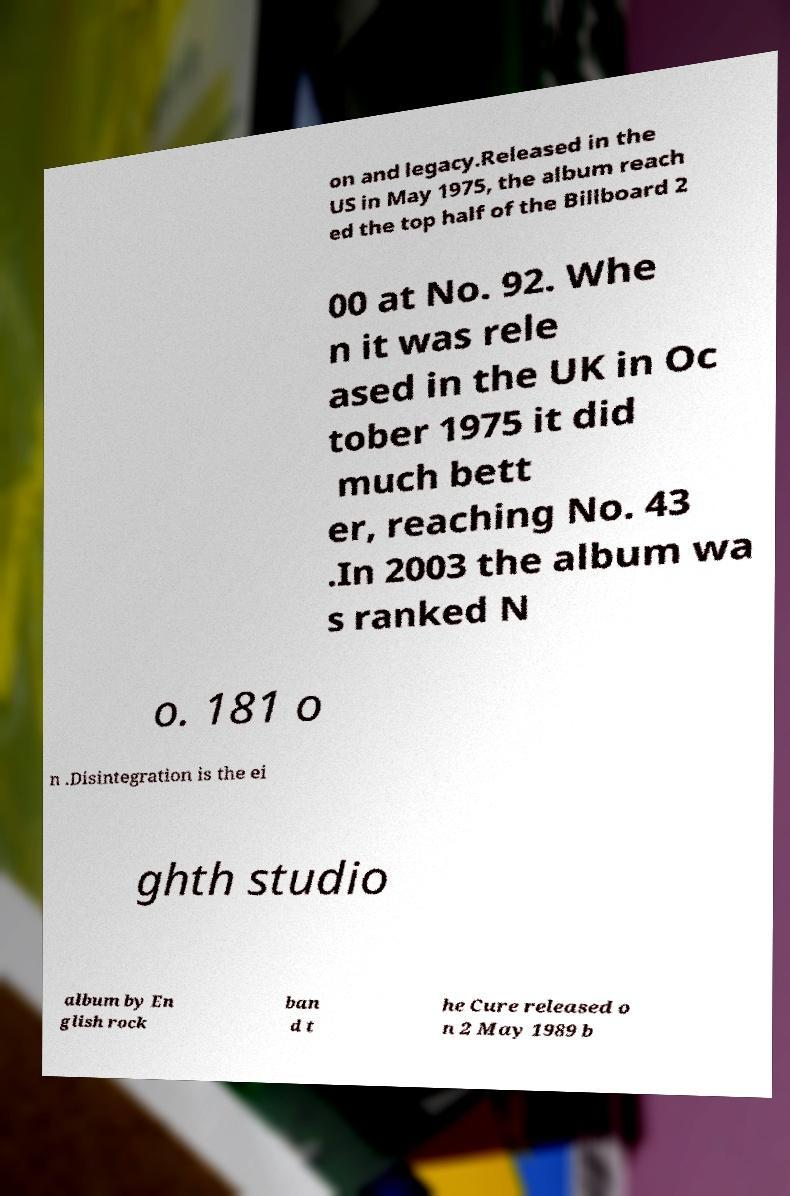Please read and relay the text visible in this image. What does it say? on and legacy.Released in the US in May 1975, the album reach ed the top half of the Billboard 2 00 at No. 92. Whe n it was rele ased in the UK in Oc tober 1975 it did much bett er, reaching No. 43 .In 2003 the album wa s ranked N o. 181 o n .Disintegration is the ei ghth studio album by En glish rock ban d t he Cure released o n 2 May 1989 b 